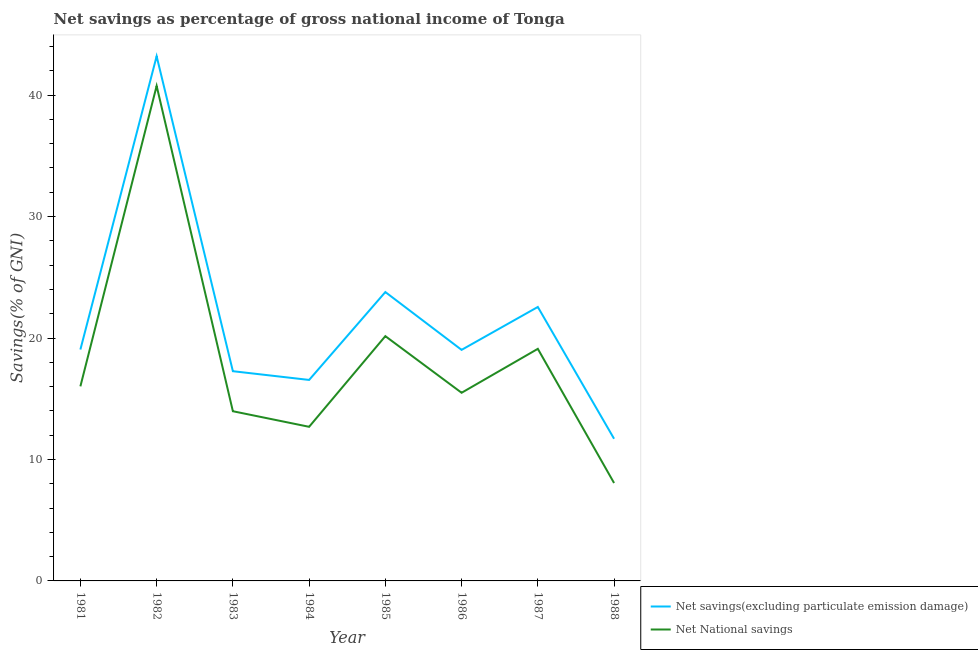How many different coloured lines are there?
Provide a short and direct response. 2. Does the line corresponding to net national savings intersect with the line corresponding to net savings(excluding particulate emission damage)?
Give a very brief answer. No. What is the net savings(excluding particulate emission damage) in 1986?
Offer a terse response. 19.02. Across all years, what is the maximum net savings(excluding particulate emission damage)?
Provide a succinct answer. 43.2. Across all years, what is the minimum net national savings?
Provide a succinct answer. 8.06. In which year was the net savings(excluding particulate emission damage) minimum?
Provide a succinct answer. 1988. What is the total net national savings in the graph?
Offer a very short reply. 146.26. What is the difference between the net national savings in 1981 and that in 1988?
Keep it short and to the point. 7.96. What is the difference between the net national savings in 1984 and the net savings(excluding particulate emission damage) in 1985?
Provide a succinct answer. -11.1. What is the average net savings(excluding particulate emission damage) per year?
Your response must be concise. 21.64. In the year 1981, what is the difference between the net savings(excluding particulate emission damage) and net national savings?
Offer a terse response. 3.03. In how many years, is the net savings(excluding particulate emission damage) greater than 2 %?
Provide a succinct answer. 8. What is the ratio of the net national savings in 1983 to that in 1988?
Your answer should be very brief. 1.73. What is the difference between the highest and the second highest net savings(excluding particulate emission damage)?
Your answer should be compact. 19.42. What is the difference between the highest and the lowest net national savings?
Your answer should be very brief. 32.7. In how many years, is the net savings(excluding particulate emission damage) greater than the average net savings(excluding particulate emission damage) taken over all years?
Your answer should be compact. 3. Is the sum of the net savings(excluding particulate emission damage) in 1981 and 1987 greater than the maximum net national savings across all years?
Your answer should be very brief. Yes. Is the net national savings strictly less than the net savings(excluding particulate emission damage) over the years?
Ensure brevity in your answer.  Yes. How many years are there in the graph?
Your answer should be compact. 8. Are the values on the major ticks of Y-axis written in scientific E-notation?
Provide a succinct answer. No. What is the title of the graph?
Your answer should be very brief. Net savings as percentage of gross national income of Tonga. Does "Methane" appear as one of the legend labels in the graph?
Your response must be concise. No. What is the label or title of the X-axis?
Offer a terse response. Year. What is the label or title of the Y-axis?
Ensure brevity in your answer.  Savings(% of GNI). What is the Savings(% of GNI) of Net savings(excluding particulate emission damage) in 1981?
Provide a succinct answer. 19.05. What is the Savings(% of GNI) in Net National savings in 1981?
Provide a succinct answer. 16.02. What is the Savings(% of GNI) in Net savings(excluding particulate emission damage) in 1982?
Provide a short and direct response. 43.2. What is the Savings(% of GNI) in Net National savings in 1982?
Provide a succinct answer. 40.76. What is the Savings(% of GNI) in Net savings(excluding particulate emission damage) in 1983?
Your response must be concise. 17.27. What is the Savings(% of GNI) in Net National savings in 1983?
Your answer should be very brief. 13.97. What is the Savings(% of GNI) in Net savings(excluding particulate emission damage) in 1984?
Offer a terse response. 16.55. What is the Savings(% of GNI) in Net National savings in 1984?
Your answer should be compact. 12.69. What is the Savings(% of GNI) in Net savings(excluding particulate emission damage) in 1985?
Offer a terse response. 23.79. What is the Savings(% of GNI) in Net National savings in 1985?
Ensure brevity in your answer.  20.15. What is the Savings(% of GNI) of Net savings(excluding particulate emission damage) in 1986?
Provide a short and direct response. 19.02. What is the Savings(% of GNI) of Net National savings in 1986?
Make the answer very short. 15.49. What is the Savings(% of GNI) of Net savings(excluding particulate emission damage) in 1987?
Keep it short and to the point. 22.56. What is the Savings(% of GNI) in Net National savings in 1987?
Offer a very short reply. 19.11. What is the Savings(% of GNI) of Net savings(excluding particulate emission damage) in 1988?
Your answer should be compact. 11.71. What is the Savings(% of GNI) in Net National savings in 1988?
Provide a short and direct response. 8.06. Across all years, what is the maximum Savings(% of GNI) in Net savings(excluding particulate emission damage)?
Your response must be concise. 43.2. Across all years, what is the maximum Savings(% of GNI) of Net National savings?
Offer a terse response. 40.76. Across all years, what is the minimum Savings(% of GNI) in Net savings(excluding particulate emission damage)?
Your response must be concise. 11.71. Across all years, what is the minimum Savings(% of GNI) of Net National savings?
Provide a short and direct response. 8.06. What is the total Savings(% of GNI) in Net savings(excluding particulate emission damage) in the graph?
Provide a short and direct response. 173.14. What is the total Savings(% of GNI) in Net National savings in the graph?
Provide a succinct answer. 146.26. What is the difference between the Savings(% of GNI) in Net savings(excluding particulate emission damage) in 1981 and that in 1982?
Provide a succinct answer. -24.15. What is the difference between the Savings(% of GNI) of Net National savings in 1981 and that in 1982?
Your answer should be very brief. -24.74. What is the difference between the Savings(% of GNI) of Net savings(excluding particulate emission damage) in 1981 and that in 1983?
Ensure brevity in your answer.  1.78. What is the difference between the Savings(% of GNI) in Net National savings in 1981 and that in 1983?
Your answer should be compact. 2.05. What is the difference between the Savings(% of GNI) in Net savings(excluding particulate emission damage) in 1981 and that in 1984?
Your answer should be compact. 2.5. What is the difference between the Savings(% of GNI) in Net National savings in 1981 and that in 1984?
Provide a succinct answer. 3.33. What is the difference between the Savings(% of GNI) in Net savings(excluding particulate emission damage) in 1981 and that in 1985?
Offer a terse response. -4.73. What is the difference between the Savings(% of GNI) of Net National savings in 1981 and that in 1985?
Your response must be concise. -4.13. What is the difference between the Savings(% of GNI) of Net savings(excluding particulate emission damage) in 1981 and that in 1986?
Provide a succinct answer. 0.03. What is the difference between the Savings(% of GNI) in Net National savings in 1981 and that in 1986?
Give a very brief answer. 0.53. What is the difference between the Savings(% of GNI) in Net savings(excluding particulate emission damage) in 1981 and that in 1987?
Provide a succinct answer. -3.5. What is the difference between the Savings(% of GNI) in Net National savings in 1981 and that in 1987?
Ensure brevity in your answer.  -3.09. What is the difference between the Savings(% of GNI) in Net savings(excluding particulate emission damage) in 1981 and that in 1988?
Your answer should be very brief. 7.35. What is the difference between the Savings(% of GNI) in Net National savings in 1981 and that in 1988?
Your answer should be very brief. 7.96. What is the difference between the Savings(% of GNI) in Net savings(excluding particulate emission damage) in 1982 and that in 1983?
Keep it short and to the point. 25.94. What is the difference between the Savings(% of GNI) of Net National savings in 1982 and that in 1983?
Provide a short and direct response. 26.79. What is the difference between the Savings(% of GNI) in Net savings(excluding particulate emission damage) in 1982 and that in 1984?
Your answer should be very brief. 26.65. What is the difference between the Savings(% of GNI) in Net National savings in 1982 and that in 1984?
Provide a succinct answer. 28.07. What is the difference between the Savings(% of GNI) of Net savings(excluding particulate emission damage) in 1982 and that in 1985?
Provide a short and direct response. 19.42. What is the difference between the Savings(% of GNI) of Net National savings in 1982 and that in 1985?
Ensure brevity in your answer.  20.61. What is the difference between the Savings(% of GNI) in Net savings(excluding particulate emission damage) in 1982 and that in 1986?
Keep it short and to the point. 24.18. What is the difference between the Savings(% of GNI) in Net National savings in 1982 and that in 1986?
Ensure brevity in your answer.  25.27. What is the difference between the Savings(% of GNI) in Net savings(excluding particulate emission damage) in 1982 and that in 1987?
Provide a short and direct response. 20.65. What is the difference between the Savings(% of GNI) of Net National savings in 1982 and that in 1987?
Give a very brief answer. 21.65. What is the difference between the Savings(% of GNI) of Net savings(excluding particulate emission damage) in 1982 and that in 1988?
Give a very brief answer. 31.5. What is the difference between the Savings(% of GNI) of Net National savings in 1982 and that in 1988?
Give a very brief answer. 32.7. What is the difference between the Savings(% of GNI) of Net savings(excluding particulate emission damage) in 1983 and that in 1984?
Make the answer very short. 0.72. What is the difference between the Savings(% of GNI) of Net National savings in 1983 and that in 1984?
Your response must be concise. 1.28. What is the difference between the Savings(% of GNI) of Net savings(excluding particulate emission damage) in 1983 and that in 1985?
Your answer should be very brief. -6.52. What is the difference between the Savings(% of GNI) of Net National savings in 1983 and that in 1985?
Offer a terse response. -6.18. What is the difference between the Savings(% of GNI) of Net savings(excluding particulate emission damage) in 1983 and that in 1986?
Provide a short and direct response. -1.76. What is the difference between the Savings(% of GNI) of Net National savings in 1983 and that in 1986?
Your answer should be compact. -1.52. What is the difference between the Savings(% of GNI) in Net savings(excluding particulate emission damage) in 1983 and that in 1987?
Ensure brevity in your answer.  -5.29. What is the difference between the Savings(% of GNI) in Net National savings in 1983 and that in 1987?
Provide a succinct answer. -5.14. What is the difference between the Savings(% of GNI) of Net savings(excluding particulate emission damage) in 1983 and that in 1988?
Provide a short and direct response. 5.56. What is the difference between the Savings(% of GNI) in Net National savings in 1983 and that in 1988?
Keep it short and to the point. 5.91. What is the difference between the Savings(% of GNI) in Net savings(excluding particulate emission damage) in 1984 and that in 1985?
Make the answer very short. -7.24. What is the difference between the Savings(% of GNI) in Net National savings in 1984 and that in 1985?
Offer a very short reply. -7.46. What is the difference between the Savings(% of GNI) of Net savings(excluding particulate emission damage) in 1984 and that in 1986?
Make the answer very short. -2.48. What is the difference between the Savings(% of GNI) in Net National savings in 1984 and that in 1986?
Make the answer very short. -2.8. What is the difference between the Savings(% of GNI) in Net savings(excluding particulate emission damage) in 1984 and that in 1987?
Offer a terse response. -6.01. What is the difference between the Savings(% of GNI) in Net National savings in 1984 and that in 1987?
Offer a terse response. -6.42. What is the difference between the Savings(% of GNI) of Net savings(excluding particulate emission damage) in 1984 and that in 1988?
Your answer should be compact. 4.84. What is the difference between the Savings(% of GNI) of Net National savings in 1984 and that in 1988?
Your response must be concise. 4.63. What is the difference between the Savings(% of GNI) of Net savings(excluding particulate emission damage) in 1985 and that in 1986?
Give a very brief answer. 4.76. What is the difference between the Savings(% of GNI) in Net National savings in 1985 and that in 1986?
Provide a succinct answer. 4.66. What is the difference between the Savings(% of GNI) of Net savings(excluding particulate emission damage) in 1985 and that in 1987?
Offer a terse response. 1.23. What is the difference between the Savings(% of GNI) in Net National savings in 1985 and that in 1987?
Your answer should be compact. 1.04. What is the difference between the Savings(% of GNI) in Net savings(excluding particulate emission damage) in 1985 and that in 1988?
Offer a very short reply. 12.08. What is the difference between the Savings(% of GNI) in Net National savings in 1985 and that in 1988?
Make the answer very short. 12.09. What is the difference between the Savings(% of GNI) of Net savings(excluding particulate emission damage) in 1986 and that in 1987?
Your answer should be very brief. -3.53. What is the difference between the Savings(% of GNI) in Net National savings in 1986 and that in 1987?
Give a very brief answer. -3.62. What is the difference between the Savings(% of GNI) in Net savings(excluding particulate emission damage) in 1986 and that in 1988?
Your answer should be compact. 7.32. What is the difference between the Savings(% of GNI) of Net National savings in 1986 and that in 1988?
Offer a terse response. 7.43. What is the difference between the Savings(% of GNI) in Net savings(excluding particulate emission damage) in 1987 and that in 1988?
Offer a terse response. 10.85. What is the difference between the Savings(% of GNI) in Net National savings in 1987 and that in 1988?
Your response must be concise. 11.05. What is the difference between the Savings(% of GNI) of Net savings(excluding particulate emission damage) in 1981 and the Savings(% of GNI) of Net National savings in 1982?
Offer a very short reply. -21.71. What is the difference between the Savings(% of GNI) of Net savings(excluding particulate emission damage) in 1981 and the Savings(% of GNI) of Net National savings in 1983?
Provide a short and direct response. 5.08. What is the difference between the Savings(% of GNI) of Net savings(excluding particulate emission damage) in 1981 and the Savings(% of GNI) of Net National savings in 1984?
Your answer should be compact. 6.36. What is the difference between the Savings(% of GNI) in Net savings(excluding particulate emission damage) in 1981 and the Savings(% of GNI) in Net National savings in 1985?
Give a very brief answer. -1.1. What is the difference between the Savings(% of GNI) of Net savings(excluding particulate emission damage) in 1981 and the Savings(% of GNI) of Net National savings in 1986?
Give a very brief answer. 3.56. What is the difference between the Savings(% of GNI) of Net savings(excluding particulate emission damage) in 1981 and the Savings(% of GNI) of Net National savings in 1987?
Provide a succinct answer. -0.06. What is the difference between the Savings(% of GNI) of Net savings(excluding particulate emission damage) in 1981 and the Savings(% of GNI) of Net National savings in 1988?
Keep it short and to the point. 10.99. What is the difference between the Savings(% of GNI) of Net savings(excluding particulate emission damage) in 1982 and the Savings(% of GNI) of Net National savings in 1983?
Make the answer very short. 29.23. What is the difference between the Savings(% of GNI) in Net savings(excluding particulate emission damage) in 1982 and the Savings(% of GNI) in Net National savings in 1984?
Your answer should be compact. 30.51. What is the difference between the Savings(% of GNI) of Net savings(excluding particulate emission damage) in 1982 and the Savings(% of GNI) of Net National savings in 1985?
Provide a short and direct response. 23.05. What is the difference between the Savings(% of GNI) in Net savings(excluding particulate emission damage) in 1982 and the Savings(% of GNI) in Net National savings in 1986?
Offer a very short reply. 27.71. What is the difference between the Savings(% of GNI) of Net savings(excluding particulate emission damage) in 1982 and the Savings(% of GNI) of Net National savings in 1987?
Give a very brief answer. 24.09. What is the difference between the Savings(% of GNI) of Net savings(excluding particulate emission damage) in 1982 and the Savings(% of GNI) of Net National savings in 1988?
Your answer should be compact. 35.14. What is the difference between the Savings(% of GNI) in Net savings(excluding particulate emission damage) in 1983 and the Savings(% of GNI) in Net National savings in 1984?
Give a very brief answer. 4.58. What is the difference between the Savings(% of GNI) in Net savings(excluding particulate emission damage) in 1983 and the Savings(% of GNI) in Net National savings in 1985?
Give a very brief answer. -2.89. What is the difference between the Savings(% of GNI) in Net savings(excluding particulate emission damage) in 1983 and the Savings(% of GNI) in Net National savings in 1986?
Provide a short and direct response. 1.78. What is the difference between the Savings(% of GNI) of Net savings(excluding particulate emission damage) in 1983 and the Savings(% of GNI) of Net National savings in 1987?
Make the answer very short. -1.84. What is the difference between the Savings(% of GNI) of Net savings(excluding particulate emission damage) in 1983 and the Savings(% of GNI) of Net National savings in 1988?
Ensure brevity in your answer.  9.21. What is the difference between the Savings(% of GNI) in Net savings(excluding particulate emission damage) in 1984 and the Savings(% of GNI) in Net National savings in 1985?
Provide a succinct answer. -3.61. What is the difference between the Savings(% of GNI) in Net savings(excluding particulate emission damage) in 1984 and the Savings(% of GNI) in Net National savings in 1986?
Offer a terse response. 1.06. What is the difference between the Savings(% of GNI) in Net savings(excluding particulate emission damage) in 1984 and the Savings(% of GNI) in Net National savings in 1987?
Provide a succinct answer. -2.56. What is the difference between the Savings(% of GNI) in Net savings(excluding particulate emission damage) in 1984 and the Savings(% of GNI) in Net National savings in 1988?
Provide a succinct answer. 8.49. What is the difference between the Savings(% of GNI) in Net savings(excluding particulate emission damage) in 1985 and the Savings(% of GNI) in Net National savings in 1986?
Offer a very short reply. 8.29. What is the difference between the Savings(% of GNI) of Net savings(excluding particulate emission damage) in 1985 and the Savings(% of GNI) of Net National savings in 1987?
Provide a short and direct response. 4.68. What is the difference between the Savings(% of GNI) in Net savings(excluding particulate emission damage) in 1985 and the Savings(% of GNI) in Net National savings in 1988?
Ensure brevity in your answer.  15.72. What is the difference between the Savings(% of GNI) of Net savings(excluding particulate emission damage) in 1986 and the Savings(% of GNI) of Net National savings in 1987?
Your answer should be very brief. -0.09. What is the difference between the Savings(% of GNI) in Net savings(excluding particulate emission damage) in 1986 and the Savings(% of GNI) in Net National savings in 1988?
Your answer should be very brief. 10.96. What is the difference between the Savings(% of GNI) in Net savings(excluding particulate emission damage) in 1987 and the Savings(% of GNI) in Net National savings in 1988?
Provide a succinct answer. 14.49. What is the average Savings(% of GNI) in Net savings(excluding particulate emission damage) per year?
Make the answer very short. 21.64. What is the average Savings(% of GNI) in Net National savings per year?
Your answer should be compact. 18.28. In the year 1981, what is the difference between the Savings(% of GNI) of Net savings(excluding particulate emission damage) and Savings(% of GNI) of Net National savings?
Provide a short and direct response. 3.03. In the year 1982, what is the difference between the Savings(% of GNI) in Net savings(excluding particulate emission damage) and Savings(% of GNI) in Net National savings?
Give a very brief answer. 2.44. In the year 1983, what is the difference between the Savings(% of GNI) in Net savings(excluding particulate emission damage) and Savings(% of GNI) in Net National savings?
Your response must be concise. 3.3. In the year 1984, what is the difference between the Savings(% of GNI) in Net savings(excluding particulate emission damage) and Savings(% of GNI) in Net National savings?
Provide a short and direct response. 3.86. In the year 1985, what is the difference between the Savings(% of GNI) of Net savings(excluding particulate emission damage) and Savings(% of GNI) of Net National savings?
Your response must be concise. 3.63. In the year 1986, what is the difference between the Savings(% of GNI) of Net savings(excluding particulate emission damage) and Savings(% of GNI) of Net National savings?
Make the answer very short. 3.53. In the year 1987, what is the difference between the Savings(% of GNI) in Net savings(excluding particulate emission damage) and Savings(% of GNI) in Net National savings?
Offer a terse response. 3.45. In the year 1988, what is the difference between the Savings(% of GNI) of Net savings(excluding particulate emission damage) and Savings(% of GNI) of Net National savings?
Make the answer very short. 3.64. What is the ratio of the Savings(% of GNI) in Net savings(excluding particulate emission damage) in 1981 to that in 1982?
Ensure brevity in your answer.  0.44. What is the ratio of the Savings(% of GNI) of Net National savings in 1981 to that in 1982?
Make the answer very short. 0.39. What is the ratio of the Savings(% of GNI) of Net savings(excluding particulate emission damage) in 1981 to that in 1983?
Your answer should be very brief. 1.1. What is the ratio of the Savings(% of GNI) in Net National savings in 1981 to that in 1983?
Offer a terse response. 1.15. What is the ratio of the Savings(% of GNI) of Net savings(excluding particulate emission damage) in 1981 to that in 1984?
Make the answer very short. 1.15. What is the ratio of the Savings(% of GNI) of Net National savings in 1981 to that in 1984?
Keep it short and to the point. 1.26. What is the ratio of the Savings(% of GNI) in Net savings(excluding particulate emission damage) in 1981 to that in 1985?
Offer a terse response. 0.8. What is the ratio of the Savings(% of GNI) of Net National savings in 1981 to that in 1985?
Offer a terse response. 0.79. What is the ratio of the Savings(% of GNI) of Net National savings in 1981 to that in 1986?
Ensure brevity in your answer.  1.03. What is the ratio of the Savings(% of GNI) in Net savings(excluding particulate emission damage) in 1981 to that in 1987?
Your answer should be compact. 0.84. What is the ratio of the Savings(% of GNI) in Net National savings in 1981 to that in 1987?
Give a very brief answer. 0.84. What is the ratio of the Savings(% of GNI) in Net savings(excluding particulate emission damage) in 1981 to that in 1988?
Your answer should be compact. 1.63. What is the ratio of the Savings(% of GNI) in Net National savings in 1981 to that in 1988?
Keep it short and to the point. 1.99. What is the ratio of the Savings(% of GNI) of Net savings(excluding particulate emission damage) in 1982 to that in 1983?
Offer a terse response. 2.5. What is the ratio of the Savings(% of GNI) of Net National savings in 1982 to that in 1983?
Offer a very short reply. 2.92. What is the ratio of the Savings(% of GNI) in Net savings(excluding particulate emission damage) in 1982 to that in 1984?
Give a very brief answer. 2.61. What is the ratio of the Savings(% of GNI) in Net National savings in 1982 to that in 1984?
Keep it short and to the point. 3.21. What is the ratio of the Savings(% of GNI) in Net savings(excluding particulate emission damage) in 1982 to that in 1985?
Offer a terse response. 1.82. What is the ratio of the Savings(% of GNI) of Net National savings in 1982 to that in 1985?
Offer a terse response. 2.02. What is the ratio of the Savings(% of GNI) of Net savings(excluding particulate emission damage) in 1982 to that in 1986?
Your response must be concise. 2.27. What is the ratio of the Savings(% of GNI) of Net National savings in 1982 to that in 1986?
Ensure brevity in your answer.  2.63. What is the ratio of the Savings(% of GNI) in Net savings(excluding particulate emission damage) in 1982 to that in 1987?
Ensure brevity in your answer.  1.92. What is the ratio of the Savings(% of GNI) in Net National savings in 1982 to that in 1987?
Ensure brevity in your answer.  2.13. What is the ratio of the Savings(% of GNI) in Net savings(excluding particulate emission damage) in 1982 to that in 1988?
Provide a succinct answer. 3.69. What is the ratio of the Savings(% of GNI) of Net National savings in 1982 to that in 1988?
Provide a short and direct response. 5.06. What is the ratio of the Savings(% of GNI) of Net savings(excluding particulate emission damage) in 1983 to that in 1984?
Provide a short and direct response. 1.04. What is the ratio of the Savings(% of GNI) of Net National savings in 1983 to that in 1984?
Provide a short and direct response. 1.1. What is the ratio of the Savings(% of GNI) of Net savings(excluding particulate emission damage) in 1983 to that in 1985?
Your response must be concise. 0.73. What is the ratio of the Savings(% of GNI) in Net National savings in 1983 to that in 1985?
Your answer should be very brief. 0.69. What is the ratio of the Savings(% of GNI) of Net savings(excluding particulate emission damage) in 1983 to that in 1986?
Provide a succinct answer. 0.91. What is the ratio of the Savings(% of GNI) of Net National savings in 1983 to that in 1986?
Give a very brief answer. 0.9. What is the ratio of the Savings(% of GNI) in Net savings(excluding particulate emission damage) in 1983 to that in 1987?
Ensure brevity in your answer.  0.77. What is the ratio of the Savings(% of GNI) of Net National savings in 1983 to that in 1987?
Provide a short and direct response. 0.73. What is the ratio of the Savings(% of GNI) in Net savings(excluding particulate emission damage) in 1983 to that in 1988?
Offer a terse response. 1.48. What is the ratio of the Savings(% of GNI) of Net National savings in 1983 to that in 1988?
Give a very brief answer. 1.73. What is the ratio of the Savings(% of GNI) in Net savings(excluding particulate emission damage) in 1984 to that in 1985?
Provide a short and direct response. 0.7. What is the ratio of the Savings(% of GNI) of Net National savings in 1984 to that in 1985?
Your answer should be compact. 0.63. What is the ratio of the Savings(% of GNI) in Net savings(excluding particulate emission damage) in 1984 to that in 1986?
Your answer should be compact. 0.87. What is the ratio of the Savings(% of GNI) in Net National savings in 1984 to that in 1986?
Offer a terse response. 0.82. What is the ratio of the Savings(% of GNI) in Net savings(excluding particulate emission damage) in 1984 to that in 1987?
Keep it short and to the point. 0.73. What is the ratio of the Savings(% of GNI) in Net National savings in 1984 to that in 1987?
Your answer should be very brief. 0.66. What is the ratio of the Savings(% of GNI) of Net savings(excluding particulate emission damage) in 1984 to that in 1988?
Offer a very short reply. 1.41. What is the ratio of the Savings(% of GNI) in Net National savings in 1984 to that in 1988?
Your answer should be very brief. 1.57. What is the ratio of the Savings(% of GNI) of Net savings(excluding particulate emission damage) in 1985 to that in 1986?
Your answer should be very brief. 1.25. What is the ratio of the Savings(% of GNI) in Net National savings in 1985 to that in 1986?
Offer a very short reply. 1.3. What is the ratio of the Savings(% of GNI) of Net savings(excluding particulate emission damage) in 1985 to that in 1987?
Keep it short and to the point. 1.05. What is the ratio of the Savings(% of GNI) in Net National savings in 1985 to that in 1987?
Your answer should be compact. 1.05. What is the ratio of the Savings(% of GNI) in Net savings(excluding particulate emission damage) in 1985 to that in 1988?
Give a very brief answer. 2.03. What is the ratio of the Savings(% of GNI) in Net National savings in 1985 to that in 1988?
Make the answer very short. 2.5. What is the ratio of the Savings(% of GNI) of Net savings(excluding particulate emission damage) in 1986 to that in 1987?
Make the answer very short. 0.84. What is the ratio of the Savings(% of GNI) of Net National savings in 1986 to that in 1987?
Your answer should be very brief. 0.81. What is the ratio of the Savings(% of GNI) of Net savings(excluding particulate emission damage) in 1986 to that in 1988?
Offer a terse response. 1.63. What is the ratio of the Savings(% of GNI) in Net National savings in 1986 to that in 1988?
Offer a very short reply. 1.92. What is the ratio of the Savings(% of GNI) in Net savings(excluding particulate emission damage) in 1987 to that in 1988?
Keep it short and to the point. 1.93. What is the ratio of the Savings(% of GNI) in Net National savings in 1987 to that in 1988?
Your response must be concise. 2.37. What is the difference between the highest and the second highest Savings(% of GNI) of Net savings(excluding particulate emission damage)?
Offer a terse response. 19.42. What is the difference between the highest and the second highest Savings(% of GNI) in Net National savings?
Make the answer very short. 20.61. What is the difference between the highest and the lowest Savings(% of GNI) of Net savings(excluding particulate emission damage)?
Your response must be concise. 31.5. What is the difference between the highest and the lowest Savings(% of GNI) in Net National savings?
Keep it short and to the point. 32.7. 